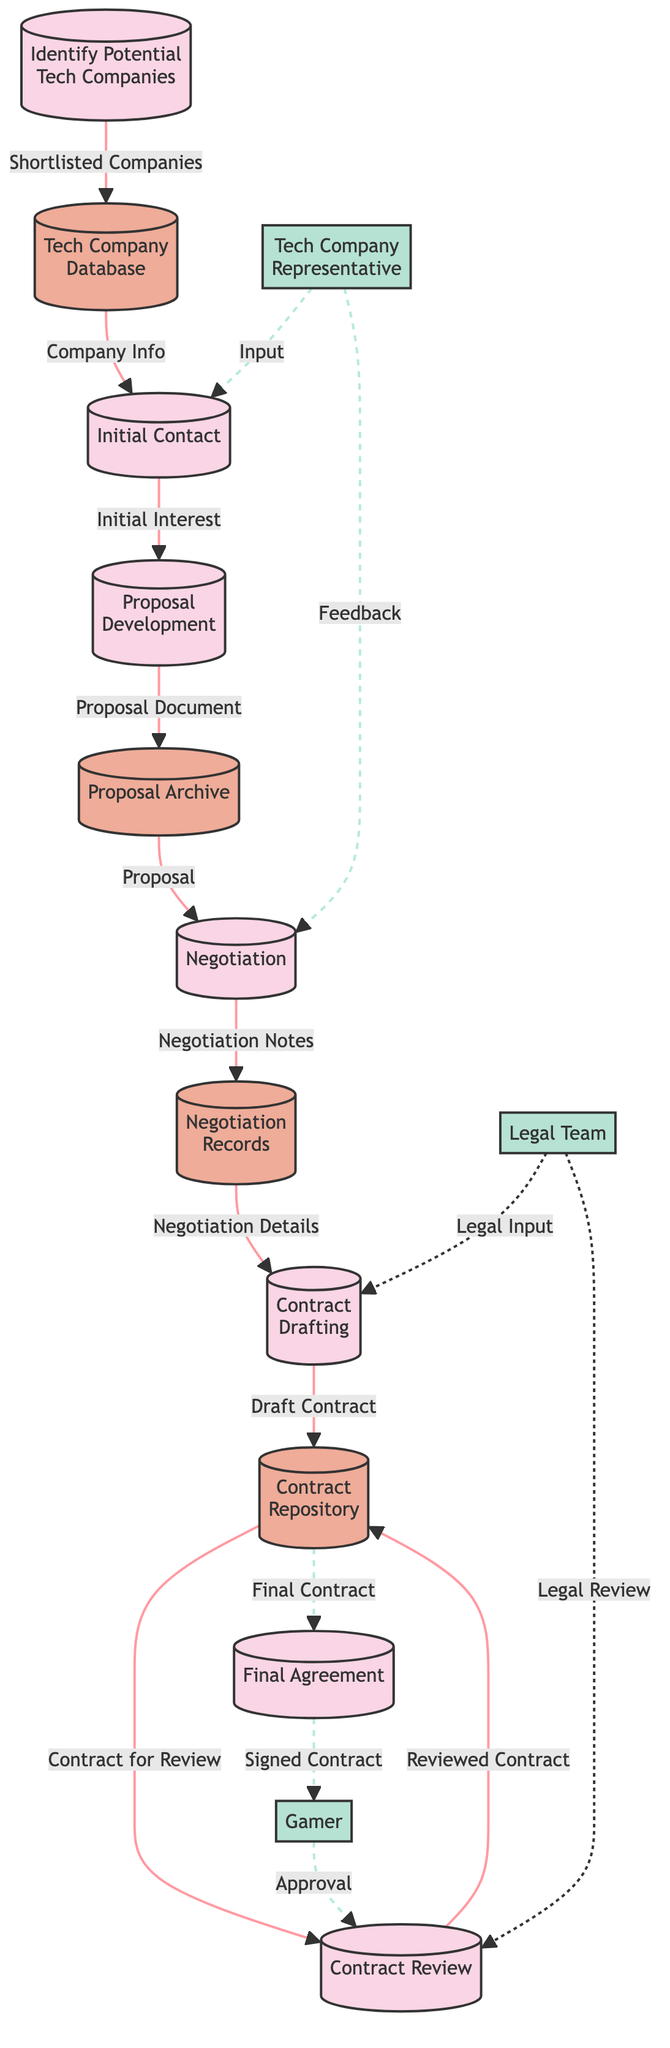What is the first process in the diagram? The first process listed is "Identify Potential Tech Companies" as it is the first item in the process list.
Answer: Identify Potential Tech Companies How many processes are there in total? The diagram includes a total of seven distinct processes.
Answer: 7 What does the Tech Company Database store? The Tech Company Database is described as storing potential tech companies and contact information.
Answer: Potential tech companies and contact information What flow occurs after the "Contract Review"? The flow that occurs after the "Contract Review" leads to the "Final Agreement" where both parties sign the finalized contract.
Answer: Final Agreement Which external entity is responsible for negotiating the deal from the tech company side? The external entity responsible for negotiating the deal is the "Tech Company Representative."
Answer: Tech Company Representative Which data store keeps track of all negotiation communications? The "Negotiation Records" data store keeps track of all negotiation communications and notes.
Answer: Negotiation Records How is the "Availability of Proposal Document" linked to "Initial Contact"? The flow connects "Initial Contact" to "Proposal Development," indicating that after reaching out, there is an expectation for the creation of a proposal based on initial interest from the tech companies.
Answer: Proposal Development In which step does the Legal Team get involved in the process? The Legal Team gets involved during the "Contract Drafting," where legal advisors from both sides help in drafting the formal contract outlining terms.
Answer: Contract Drafting What is the final outcome of the entire process depicted in the diagram? The final outcome is the "Signed Contract," which indicates that both parties have officially entered into the endorsement deal.
Answer: Signed Contract What kind of feedback does the Tech Company Representative provide during the Negotiation? The Tech Company Representative provides Feedback during the negotiation, aiding in discussing terms during the "Negotiation" process.
Answer: Feedback 